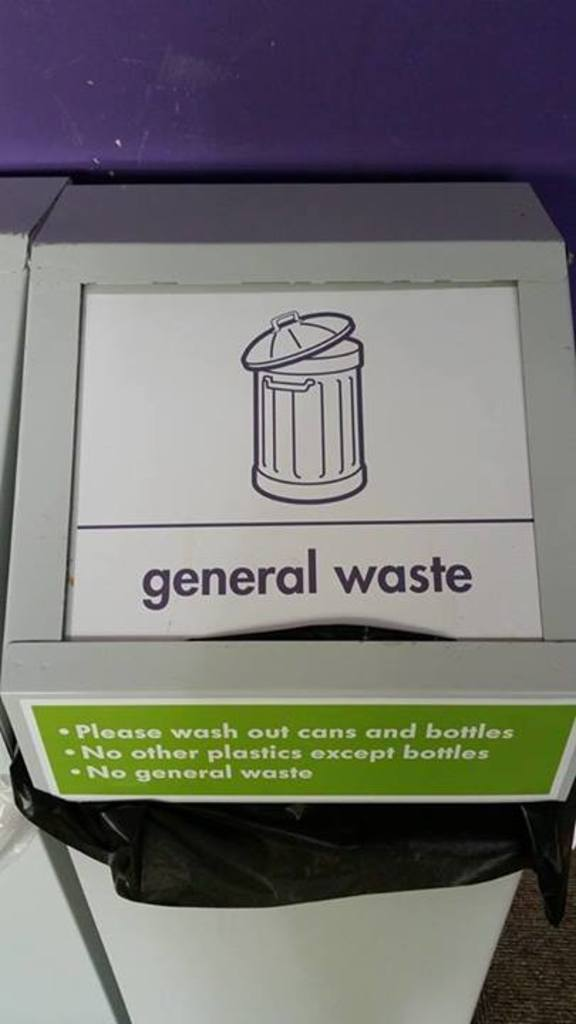What are some challenges associated with recycling plastics? Recycling plastics involves several challenges such as the need for sorting different types of plastics, the contamination risk from food residues, and the degradation in quality after recycling. Additionally, not all plastics are recyclable, which adds complexity to processing and requires clear communication, as seen in this bin's labeling. 